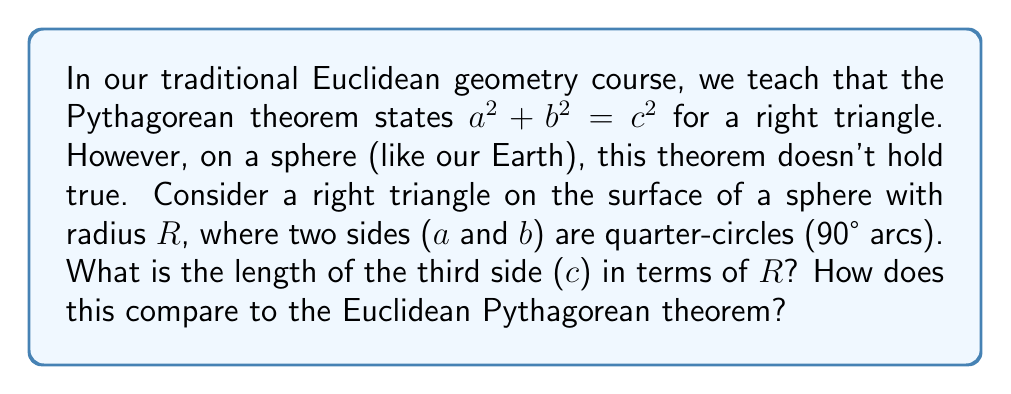What is the answer to this math problem? Let's approach this step-by-step:

1) In spherical geometry, the sides of a triangle are arcs of great circles.

2) For a right triangle with two sides as quarter-circles (90° arcs), each of these sides has a length of:

   $a = b = \frac{\pi R}{2}$

3) In spherical trigonometry, we use the spherical law of cosines instead of the Pythagorean theorem:

   $$\cos(\frac{c}{R}) = \cos(\frac{a}{R}) \cos(\frac{b}{R})$$

4) Substituting our known values:

   $$\cos(\frac{c}{R}) = \cos(\frac{\pi}{2}) \cos(\frac{\pi}{2})$$

5) We know that $\cos(\frac{\pi}{2}) = 0$, so:

   $$\cos(\frac{c}{R}) = 0 \cdot 0 = 0$$

6) The only angle between 0 and $\pi$ whose cosine is 0 is $\frac{\pi}{2}$, so:

   $$\frac{c}{R} = \frac{\pi}{2}$$

7) Therefore, the length of the third side is:

   $$c = \frac{\pi R}{2}$$

8) Comparing to the Euclidean Pythagorean theorem:
   - In Euclidean geometry: $a^2 + b^2 = c^2$
   - In this spherical case: $a^2 + b^2 + c^2 = \frac{3\pi^2 R^2}{4} \neq c^2$

This shows that the Pythagorean theorem doesn't hold on curved surfaces like spheres.
Answer: $c = \frac{\pi R}{2}$; differs from Euclidean as $a^2 + b^2 + c^2 = \frac{3\pi^2 R^2}{4} \neq c^2$ 